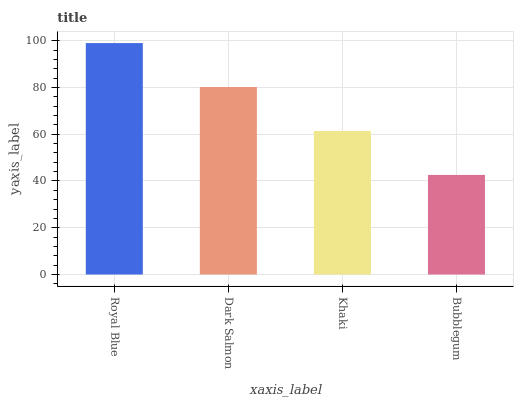Is Dark Salmon the minimum?
Answer yes or no. No. Is Dark Salmon the maximum?
Answer yes or no. No. Is Royal Blue greater than Dark Salmon?
Answer yes or no. Yes. Is Dark Salmon less than Royal Blue?
Answer yes or no. Yes. Is Dark Salmon greater than Royal Blue?
Answer yes or no. No. Is Royal Blue less than Dark Salmon?
Answer yes or no. No. Is Dark Salmon the high median?
Answer yes or no. Yes. Is Khaki the low median?
Answer yes or no. Yes. Is Royal Blue the high median?
Answer yes or no. No. Is Dark Salmon the low median?
Answer yes or no. No. 